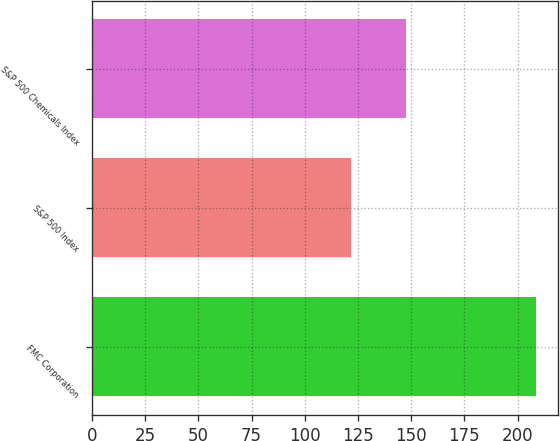<chart> <loc_0><loc_0><loc_500><loc_500><bar_chart><fcel>FMC Corporation<fcel>S&P 500 Index<fcel>S&P 500 Chemicals Index<nl><fcel>208.66<fcel>121.95<fcel>147.74<nl></chart> 